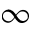<formula> <loc_0><loc_0><loc_500><loc_500>\infty</formula> 